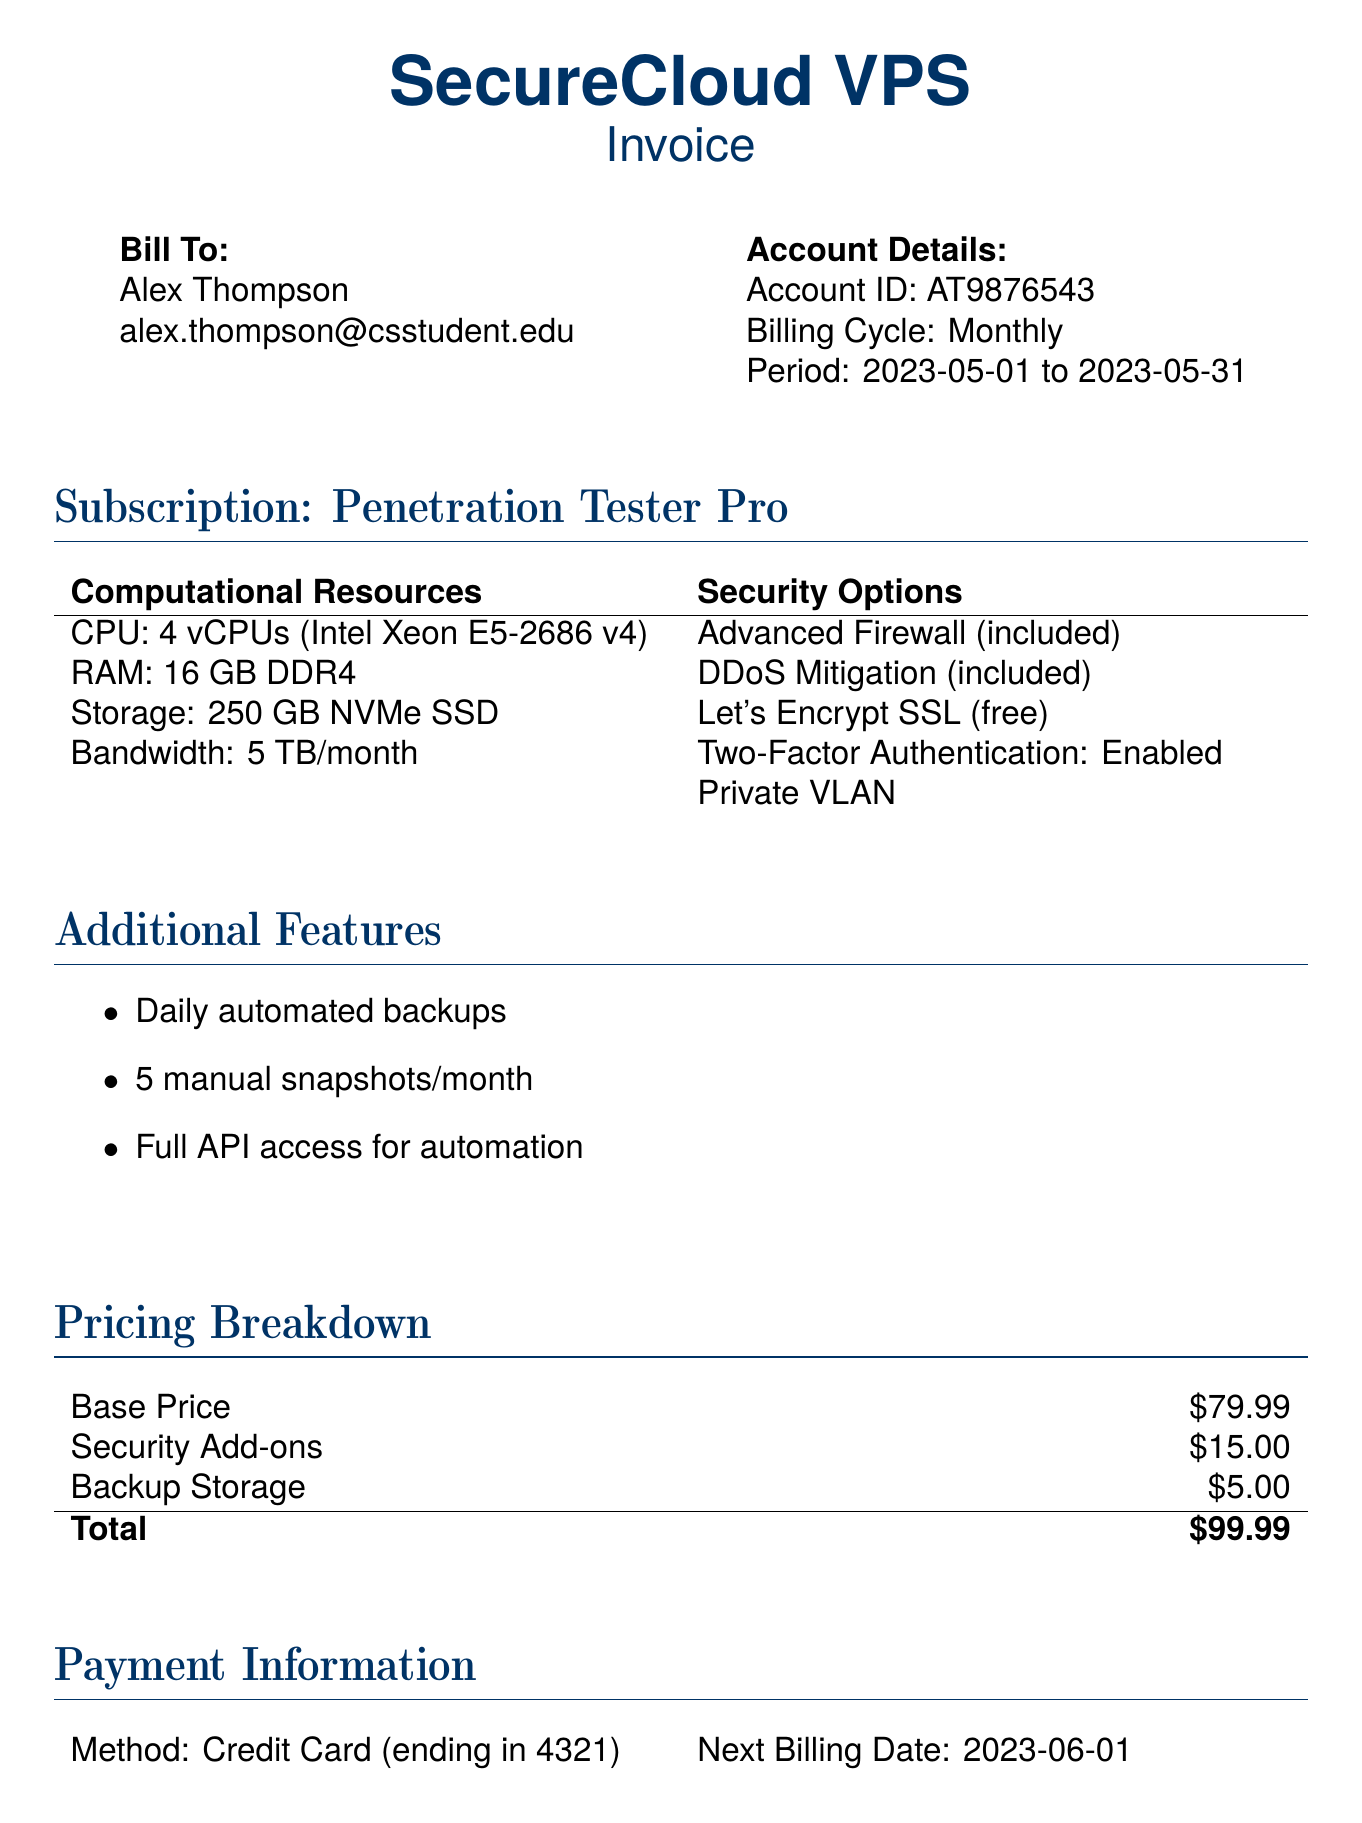What is the total amount due? The total amount due is found in the pricing breakdown section of the document, which shows the sum of all costs.
Answer: $99.99 What is the email address associated with the account? The email address is listed under the 'Bill To' section of the document.
Answer: alex.thompson@csstudent.edu How many vCPUs are included in the subscription? The number of vCPUs is specified in the computational resources section of the document.
Answer: 4 vCPUs What security feature is included for free? The document specifies a free security feature under the 'Security Options' section.
Answer: Let's Encrypt SSL What is the next billing date? The next billing date is provided in the payment information section of the document.
Answer: 2023-06-01 What is the method of payment? The method of payment is mentioned in the payment information section of the bill.
Answer: Credit Card How many manual snapshots are included per month? The number of manual snapshots is mentioned in the additional features section of the document.
Answer: 5 manual snapshots/month What is the base price of the subscription? The base price is indicated in the pricing breakdown section of the document.
Answer: $79.99 What additional feature allows for restoration of previous states? This feature is stated in the additional features section of the document.
Answer: Daily automated backups 